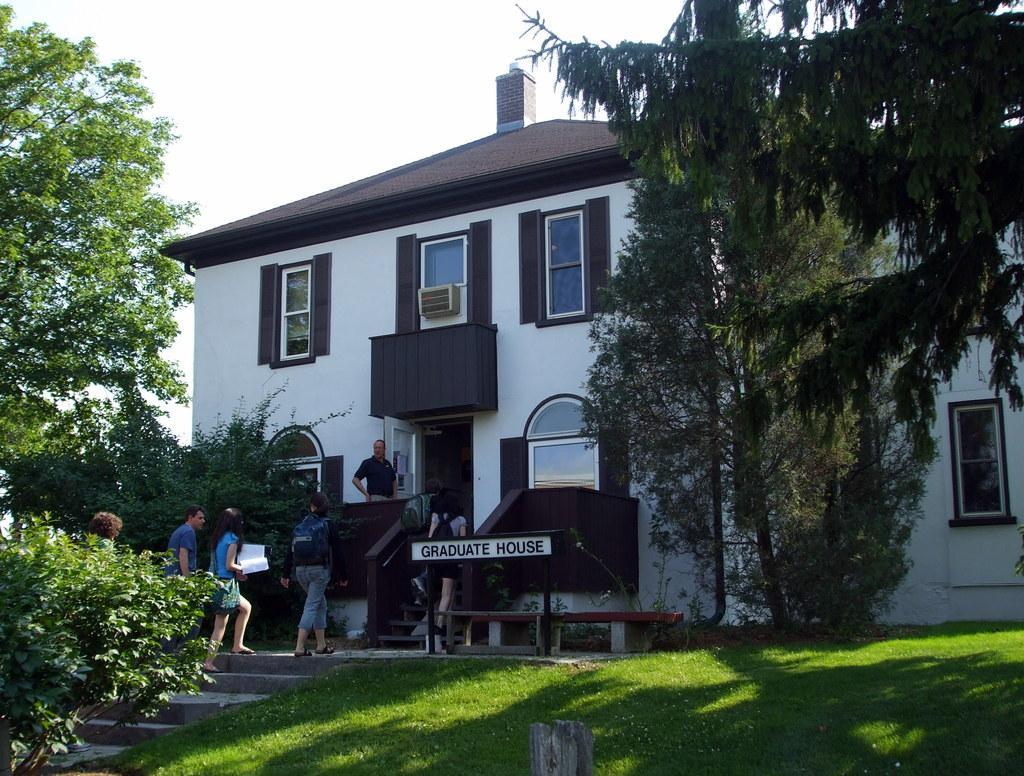In one or two sentences, can you explain what this image depicts? In the picture there is a graduation house and students are moving inside the house and there are many trees and a garden in front of the house. 